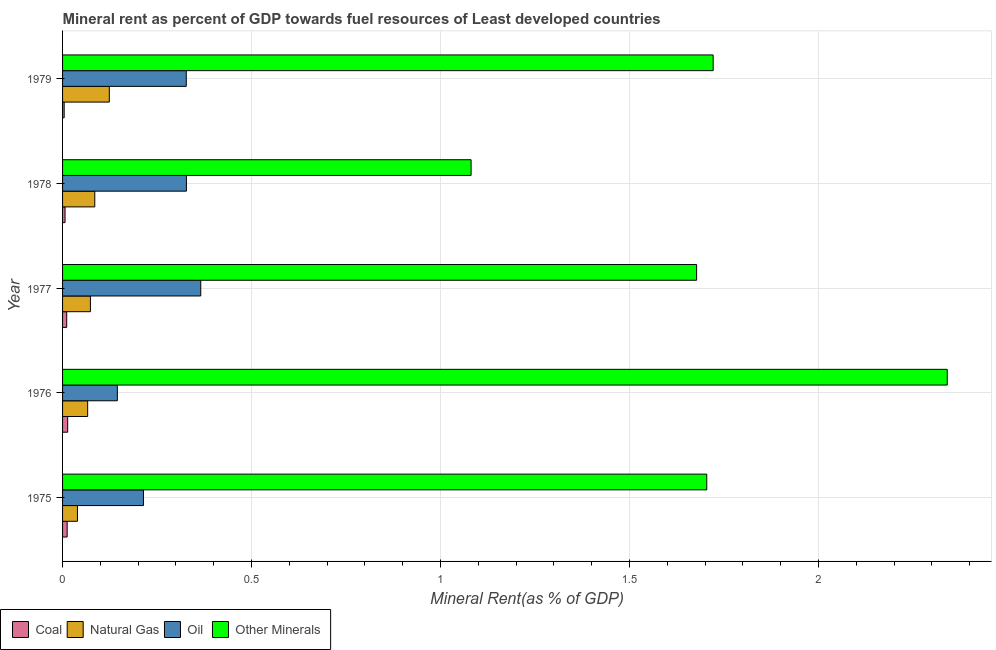How many different coloured bars are there?
Offer a very short reply. 4. How many groups of bars are there?
Offer a very short reply. 5. How many bars are there on the 2nd tick from the top?
Keep it short and to the point. 4. How many bars are there on the 1st tick from the bottom?
Your answer should be very brief. 4. What is the label of the 4th group of bars from the top?
Provide a succinct answer. 1976. What is the natural gas rent in 1975?
Keep it short and to the point. 0.04. Across all years, what is the maximum oil rent?
Provide a succinct answer. 0.37. Across all years, what is the minimum  rent of other minerals?
Your answer should be very brief. 1.08. In which year was the natural gas rent minimum?
Keep it short and to the point. 1975. What is the total  rent of other minerals in the graph?
Provide a succinct answer. 8.53. What is the difference between the natural gas rent in 1977 and that in 1978?
Your answer should be compact. -0.01. What is the difference between the oil rent in 1977 and the coal rent in 1976?
Ensure brevity in your answer.  0.35. What is the average oil rent per year?
Provide a succinct answer. 0.28. In the year 1979, what is the difference between the  rent of other minerals and natural gas rent?
Make the answer very short. 1.6. What is the ratio of the coal rent in 1976 to that in 1977?
Give a very brief answer. 1.24. Is the natural gas rent in 1975 less than that in 1976?
Your response must be concise. Yes. Is the difference between the  rent of other minerals in 1975 and 1979 greater than the difference between the coal rent in 1975 and 1979?
Ensure brevity in your answer.  No. What is the difference between the highest and the second highest oil rent?
Provide a succinct answer. 0.04. In how many years, is the oil rent greater than the average oil rent taken over all years?
Your answer should be very brief. 3. Is the sum of the oil rent in 1976 and 1977 greater than the maximum natural gas rent across all years?
Your answer should be compact. Yes. What does the 3rd bar from the top in 1978 represents?
Your response must be concise. Natural Gas. What does the 4th bar from the bottom in 1977 represents?
Keep it short and to the point. Other Minerals. Are all the bars in the graph horizontal?
Make the answer very short. Yes. What is the difference between two consecutive major ticks on the X-axis?
Give a very brief answer. 0.5. Are the values on the major ticks of X-axis written in scientific E-notation?
Make the answer very short. No. Does the graph contain any zero values?
Ensure brevity in your answer.  No. How are the legend labels stacked?
Provide a succinct answer. Horizontal. What is the title of the graph?
Give a very brief answer. Mineral rent as percent of GDP towards fuel resources of Least developed countries. Does "Energy" appear as one of the legend labels in the graph?
Make the answer very short. No. What is the label or title of the X-axis?
Your answer should be compact. Mineral Rent(as % of GDP). What is the label or title of the Y-axis?
Keep it short and to the point. Year. What is the Mineral Rent(as % of GDP) in Coal in 1975?
Your response must be concise. 0.01. What is the Mineral Rent(as % of GDP) in Natural Gas in 1975?
Your response must be concise. 0.04. What is the Mineral Rent(as % of GDP) in Oil in 1975?
Offer a very short reply. 0.21. What is the Mineral Rent(as % of GDP) of Other Minerals in 1975?
Provide a succinct answer. 1.7. What is the Mineral Rent(as % of GDP) of Coal in 1976?
Provide a short and direct response. 0.01. What is the Mineral Rent(as % of GDP) of Natural Gas in 1976?
Give a very brief answer. 0.07. What is the Mineral Rent(as % of GDP) of Oil in 1976?
Make the answer very short. 0.14. What is the Mineral Rent(as % of GDP) of Other Minerals in 1976?
Provide a short and direct response. 2.34. What is the Mineral Rent(as % of GDP) of Coal in 1977?
Your answer should be compact. 0.01. What is the Mineral Rent(as % of GDP) of Natural Gas in 1977?
Give a very brief answer. 0.07. What is the Mineral Rent(as % of GDP) of Oil in 1977?
Your answer should be very brief. 0.37. What is the Mineral Rent(as % of GDP) of Other Minerals in 1977?
Provide a succinct answer. 1.68. What is the Mineral Rent(as % of GDP) in Coal in 1978?
Keep it short and to the point. 0.01. What is the Mineral Rent(as % of GDP) in Natural Gas in 1978?
Make the answer very short. 0.09. What is the Mineral Rent(as % of GDP) in Oil in 1978?
Your answer should be very brief. 0.33. What is the Mineral Rent(as % of GDP) of Other Minerals in 1978?
Offer a terse response. 1.08. What is the Mineral Rent(as % of GDP) of Coal in 1979?
Give a very brief answer. 0. What is the Mineral Rent(as % of GDP) in Natural Gas in 1979?
Give a very brief answer. 0.12. What is the Mineral Rent(as % of GDP) of Oil in 1979?
Offer a terse response. 0.33. What is the Mineral Rent(as % of GDP) in Other Minerals in 1979?
Provide a short and direct response. 1.72. Across all years, what is the maximum Mineral Rent(as % of GDP) of Coal?
Your answer should be compact. 0.01. Across all years, what is the maximum Mineral Rent(as % of GDP) of Natural Gas?
Offer a very short reply. 0.12. Across all years, what is the maximum Mineral Rent(as % of GDP) in Oil?
Keep it short and to the point. 0.37. Across all years, what is the maximum Mineral Rent(as % of GDP) of Other Minerals?
Provide a succinct answer. 2.34. Across all years, what is the minimum Mineral Rent(as % of GDP) of Coal?
Offer a terse response. 0. Across all years, what is the minimum Mineral Rent(as % of GDP) of Natural Gas?
Your response must be concise. 0.04. Across all years, what is the minimum Mineral Rent(as % of GDP) of Oil?
Ensure brevity in your answer.  0.14. Across all years, what is the minimum Mineral Rent(as % of GDP) in Other Minerals?
Provide a succinct answer. 1.08. What is the total Mineral Rent(as % of GDP) in Coal in the graph?
Make the answer very short. 0.05. What is the total Mineral Rent(as % of GDP) in Natural Gas in the graph?
Your response must be concise. 0.39. What is the total Mineral Rent(as % of GDP) in Oil in the graph?
Offer a very short reply. 1.38. What is the total Mineral Rent(as % of GDP) of Other Minerals in the graph?
Your answer should be compact. 8.53. What is the difference between the Mineral Rent(as % of GDP) of Coal in 1975 and that in 1976?
Give a very brief answer. -0. What is the difference between the Mineral Rent(as % of GDP) in Natural Gas in 1975 and that in 1976?
Your response must be concise. -0.03. What is the difference between the Mineral Rent(as % of GDP) in Oil in 1975 and that in 1976?
Make the answer very short. 0.07. What is the difference between the Mineral Rent(as % of GDP) in Other Minerals in 1975 and that in 1976?
Give a very brief answer. -0.64. What is the difference between the Mineral Rent(as % of GDP) of Coal in 1975 and that in 1977?
Offer a terse response. 0. What is the difference between the Mineral Rent(as % of GDP) in Natural Gas in 1975 and that in 1977?
Provide a short and direct response. -0.03. What is the difference between the Mineral Rent(as % of GDP) of Oil in 1975 and that in 1977?
Ensure brevity in your answer.  -0.15. What is the difference between the Mineral Rent(as % of GDP) of Other Minerals in 1975 and that in 1977?
Provide a short and direct response. 0.03. What is the difference between the Mineral Rent(as % of GDP) of Coal in 1975 and that in 1978?
Make the answer very short. 0.01. What is the difference between the Mineral Rent(as % of GDP) of Natural Gas in 1975 and that in 1978?
Provide a succinct answer. -0.05. What is the difference between the Mineral Rent(as % of GDP) in Oil in 1975 and that in 1978?
Ensure brevity in your answer.  -0.11. What is the difference between the Mineral Rent(as % of GDP) in Other Minerals in 1975 and that in 1978?
Provide a succinct answer. 0.62. What is the difference between the Mineral Rent(as % of GDP) in Coal in 1975 and that in 1979?
Offer a very short reply. 0.01. What is the difference between the Mineral Rent(as % of GDP) of Natural Gas in 1975 and that in 1979?
Keep it short and to the point. -0.08. What is the difference between the Mineral Rent(as % of GDP) of Oil in 1975 and that in 1979?
Your answer should be compact. -0.11. What is the difference between the Mineral Rent(as % of GDP) in Other Minerals in 1975 and that in 1979?
Your answer should be compact. -0.02. What is the difference between the Mineral Rent(as % of GDP) in Coal in 1976 and that in 1977?
Make the answer very short. 0. What is the difference between the Mineral Rent(as % of GDP) of Natural Gas in 1976 and that in 1977?
Provide a short and direct response. -0.01. What is the difference between the Mineral Rent(as % of GDP) of Oil in 1976 and that in 1977?
Your response must be concise. -0.22. What is the difference between the Mineral Rent(as % of GDP) of Other Minerals in 1976 and that in 1977?
Provide a succinct answer. 0.66. What is the difference between the Mineral Rent(as % of GDP) of Coal in 1976 and that in 1978?
Make the answer very short. 0.01. What is the difference between the Mineral Rent(as % of GDP) in Natural Gas in 1976 and that in 1978?
Make the answer very short. -0.02. What is the difference between the Mineral Rent(as % of GDP) of Oil in 1976 and that in 1978?
Offer a very short reply. -0.18. What is the difference between the Mineral Rent(as % of GDP) of Other Minerals in 1976 and that in 1978?
Provide a short and direct response. 1.26. What is the difference between the Mineral Rent(as % of GDP) in Coal in 1976 and that in 1979?
Ensure brevity in your answer.  0.01. What is the difference between the Mineral Rent(as % of GDP) of Natural Gas in 1976 and that in 1979?
Make the answer very short. -0.06. What is the difference between the Mineral Rent(as % of GDP) of Oil in 1976 and that in 1979?
Make the answer very short. -0.18. What is the difference between the Mineral Rent(as % of GDP) of Other Minerals in 1976 and that in 1979?
Make the answer very short. 0.62. What is the difference between the Mineral Rent(as % of GDP) of Coal in 1977 and that in 1978?
Provide a succinct answer. 0. What is the difference between the Mineral Rent(as % of GDP) in Natural Gas in 1977 and that in 1978?
Provide a short and direct response. -0.01. What is the difference between the Mineral Rent(as % of GDP) in Oil in 1977 and that in 1978?
Your response must be concise. 0.04. What is the difference between the Mineral Rent(as % of GDP) in Other Minerals in 1977 and that in 1978?
Ensure brevity in your answer.  0.6. What is the difference between the Mineral Rent(as % of GDP) in Coal in 1977 and that in 1979?
Make the answer very short. 0.01. What is the difference between the Mineral Rent(as % of GDP) of Oil in 1977 and that in 1979?
Ensure brevity in your answer.  0.04. What is the difference between the Mineral Rent(as % of GDP) in Other Minerals in 1977 and that in 1979?
Provide a succinct answer. -0.04. What is the difference between the Mineral Rent(as % of GDP) in Coal in 1978 and that in 1979?
Your response must be concise. 0. What is the difference between the Mineral Rent(as % of GDP) in Natural Gas in 1978 and that in 1979?
Make the answer very short. -0.04. What is the difference between the Mineral Rent(as % of GDP) of Oil in 1978 and that in 1979?
Make the answer very short. 0. What is the difference between the Mineral Rent(as % of GDP) in Other Minerals in 1978 and that in 1979?
Offer a very short reply. -0.64. What is the difference between the Mineral Rent(as % of GDP) of Coal in 1975 and the Mineral Rent(as % of GDP) of Natural Gas in 1976?
Your answer should be very brief. -0.05. What is the difference between the Mineral Rent(as % of GDP) of Coal in 1975 and the Mineral Rent(as % of GDP) of Oil in 1976?
Offer a terse response. -0.13. What is the difference between the Mineral Rent(as % of GDP) of Coal in 1975 and the Mineral Rent(as % of GDP) of Other Minerals in 1976?
Ensure brevity in your answer.  -2.33. What is the difference between the Mineral Rent(as % of GDP) in Natural Gas in 1975 and the Mineral Rent(as % of GDP) in Oil in 1976?
Provide a short and direct response. -0.11. What is the difference between the Mineral Rent(as % of GDP) of Natural Gas in 1975 and the Mineral Rent(as % of GDP) of Other Minerals in 1976?
Make the answer very short. -2.3. What is the difference between the Mineral Rent(as % of GDP) in Oil in 1975 and the Mineral Rent(as % of GDP) in Other Minerals in 1976?
Your answer should be compact. -2.13. What is the difference between the Mineral Rent(as % of GDP) in Coal in 1975 and the Mineral Rent(as % of GDP) in Natural Gas in 1977?
Provide a succinct answer. -0.06. What is the difference between the Mineral Rent(as % of GDP) in Coal in 1975 and the Mineral Rent(as % of GDP) in Oil in 1977?
Your answer should be compact. -0.35. What is the difference between the Mineral Rent(as % of GDP) of Coal in 1975 and the Mineral Rent(as % of GDP) of Other Minerals in 1977?
Provide a short and direct response. -1.67. What is the difference between the Mineral Rent(as % of GDP) in Natural Gas in 1975 and the Mineral Rent(as % of GDP) in Oil in 1977?
Provide a succinct answer. -0.33. What is the difference between the Mineral Rent(as % of GDP) in Natural Gas in 1975 and the Mineral Rent(as % of GDP) in Other Minerals in 1977?
Your answer should be compact. -1.64. What is the difference between the Mineral Rent(as % of GDP) in Oil in 1975 and the Mineral Rent(as % of GDP) in Other Minerals in 1977?
Your answer should be compact. -1.46. What is the difference between the Mineral Rent(as % of GDP) of Coal in 1975 and the Mineral Rent(as % of GDP) of Natural Gas in 1978?
Offer a very short reply. -0.07. What is the difference between the Mineral Rent(as % of GDP) in Coal in 1975 and the Mineral Rent(as % of GDP) in Oil in 1978?
Make the answer very short. -0.32. What is the difference between the Mineral Rent(as % of GDP) of Coal in 1975 and the Mineral Rent(as % of GDP) of Other Minerals in 1978?
Provide a short and direct response. -1.07. What is the difference between the Mineral Rent(as % of GDP) of Natural Gas in 1975 and the Mineral Rent(as % of GDP) of Oil in 1978?
Provide a short and direct response. -0.29. What is the difference between the Mineral Rent(as % of GDP) in Natural Gas in 1975 and the Mineral Rent(as % of GDP) in Other Minerals in 1978?
Provide a succinct answer. -1.04. What is the difference between the Mineral Rent(as % of GDP) in Oil in 1975 and the Mineral Rent(as % of GDP) in Other Minerals in 1978?
Give a very brief answer. -0.87. What is the difference between the Mineral Rent(as % of GDP) of Coal in 1975 and the Mineral Rent(as % of GDP) of Natural Gas in 1979?
Offer a very short reply. -0.11. What is the difference between the Mineral Rent(as % of GDP) of Coal in 1975 and the Mineral Rent(as % of GDP) of Oil in 1979?
Make the answer very short. -0.32. What is the difference between the Mineral Rent(as % of GDP) of Coal in 1975 and the Mineral Rent(as % of GDP) of Other Minerals in 1979?
Offer a very short reply. -1.71. What is the difference between the Mineral Rent(as % of GDP) in Natural Gas in 1975 and the Mineral Rent(as % of GDP) in Oil in 1979?
Provide a short and direct response. -0.29. What is the difference between the Mineral Rent(as % of GDP) in Natural Gas in 1975 and the Mineral Rent(as % of GDP) in Other Minerals in 1979?
Your answer should be compact. -1.68. What is the difference between the Mineral Rent(as % of GDP) of Oil in 1975 and the Mineral Rent(as % of GDP) of Other Minerals in 1979?
Keep it short and to the point. -1.51. What is the difference between the Mineral Rent(as % of GDP) of Coal in 1976 and the Mineral Rent(as % of GDP) of Natural Gas in 1977?
Your response must be concise. -0.06. What is the difference between the Mineral Rent(as % of GDP) in Coal in 1976 and the Mineral Rent(as % of GDP) in Oil in 1977?
Provide a succinct answer. -0.35. What is the difference between the Mineral Rent(as % of GDP) of Coal in 1976 and the Mineral Rent(as % of GDP) of Other Minerals in 1977?
Make the answer very short. -1.66. What is the difference between the Mineral Rent(as % of GDP) in Natural Gas in 1976 and the Mineral Rent(as % of GDP) in Oil in 1977?
Offer a very short reply. -0.3. What is the difference between the Mineral Rent(as % of GDP) in Natural Gas in 1976 and the Mineral Rent(as % of GDP) in Other Minerals in 1977?
Your answer should be very brief. -1.61. What is the difference between the Mineral Rent(as % of GDP) in Oil in 1976 and the Mineral Rent(as % of GDP) in Other Minerals in 1977?
Offer a terse response. -1.53. What is the difference between the Mineral Rent(as % of GDP) in Coal in 1976 and the Mineral Rent(as % of GDP) in Natural Gas in 1978?
Your answer should be very brief. -0.07. What is the difference between the Mineral Rent(as % of GDP) of Coal in 1976 and the Mineral Rent(as % of GDP) of Oil in 1978?
Offer a very short reply. -0.31. What is the difference between the Mineral Rent(as % of GDP) in Coal in 1976 and the Mineral Rent(as % of GDP) in Other Minerals in 1978?
Offer a very short reply. -1.07. What is the difference between the Mineral Rent(as % of GDP) of Natural Gas in 1976 and the Mineral Rent(as % of GDP) of Oil in 1978?
Your answer should be very brief. -0.26. What is the difference between the Mineral Rent(as % of GDP) in Natural Gas in 1976 and the Mineral Rent(as % of GDP) in Other Minerals in 1978?
Ensure brevity in your answer.  -1.01. What is the difference between the Mineral Rent(as % of GDP) in Oil in 1976 and the Mineral Rent(as % of GDP) in Other Minerals in 1978?
Your answer should be very brief. -0.94. What is the difference between the Mineral Rent(as % of GDP) of Coal in 1976 and the Mineral Rent(as % of GDP) of Natural Gas in 1979?
Your response must be concise. -0.11. What is the difference between the Mineral Rent(as % of GDP) in Coal in 1976 and the Mineral Rent(as % of GDP) in Oil in 1979?
Make the answer very short. -0.31. What is the difference between the Mineral Rent(as % of GDP) in Coal in 1976 and the Mineral Rent(as % of GDP) in Other Minerals in 1979?
Your answer should be compact. -1.71. What is the difference between the Mineral Rent(as % of GDP) in Natural Gas in 1976 and the Mineral Rent(as % of GDP) in Oil in 1979?
Provide a succinct answer. -0.26. What is the difference between the Mineral Rent(as % of GDP) in Natural Gas in 1976 and the Mineral Rent(as % of GDP) in Other Minerals in 1979?
Your answer should be very brief. -1.66. What is the difference between the Mineral Rent(as % of GDP) of Oil in 1976 and the Mineral Rent(as % of GDP) of Other Minerals in 1979?
Your answer should be compact. -1.58. What is the difference between the Mineral Rent(as % of GDP) in Coal in 1977 and the Mineral Rent(as % of GDP) in Natural Gas in 1978?
Your answer should be very brief. -0.07. What is the difference between the Mineral Rent(as % of GDP) in Coal in 1977 and the Mineral Rent(as % of GDP) in Oil in 1978?
Make the answer very short. -0.32. What is the difference between the Mineral Rent(as % of GDP) in Coal in 1977 and the Mineral Rent(as % of GDP) in Other Minerals in 1978?
Offer a very short reply. -1.07. What is the difference between the Mineral Rent(as % of GDP) of Natural Gas in 1977 and the Mineral Rent(as % of GDP) of Oil in 1978?
Provide a succinct answer. -0.25. What is the difference between the Mineral Rent(as % of GDP) in Natural Gas in 1977 and the Mineral Rent(as % of GDP) in Other Minerals in 1978?
Give a very brief answer. -1.01. What is the difference between the Mineral Rent(as % of GDP) of Oil in 1977 and the Mineral Rent(as % of GDP) of Other Minerals in 1978?
Your answer should be compact. -0.72. What is the difference between the Mineral Rent(as % of GDP) in Coal in 1977 and the Mineral Rent(as % of GDP) in Natural Gas in 1979?
Your answer should be very brief. -0.11. What is the difference between the Mineral Rent(as % of GDP) of Coal in 1977 and the Mineral Rent(as % of GDP) of Oil in 1979?
Provide a short and direct response. -0.32. What is the difference between the Mineral Rent(as % of GDP) in Coal in 1977 and the Mineral Rent(as % of GDP) in Other Minerals in 1979?
Ensure brevity in your answer.  -1.71. What is the difference between the Mineral Rent(as % of GDP) in Natural Gas in 1977 and the Mineral Rent(as % of GDP) in Oil in 1979?
Make the answer very short. -0.25. What is the difference between the Mineral Rent(as % of GDP) of Natural Gas in 1977 and the Mineral Rent(as % of GDP) of Other Minerals in 1979?
Give a very brief answer. -1.65. What is the difference between the Mineral Rent(as % of GDP) in Oil in 1977 and the Mineral Rent(as % of GDP) in Other Minerals in 1979?
Offer a terse response. -1.36. What is the difference between the Mineral Rent(as % of GDP) of Coal in 1978 and the Mineral Rent(as % of GDP) of Natural Gas in 1979?
Offer a terse response. -0.12. What is the difference between the Mineral Rent(as % of GDP) in Coal in 1978 and the Mineral Rent(as % of GDP) in Oil in 1979?
Your answer should be compact. -0.32. What is the difference between the Mineral Rent(as % of GDP) in Coal in 1978 and the Mineral Rent(as % of GDP) in Other Minerals in 1979?
Offer a terse response. -1.71. What is the difference between the Mineral Rent(as % of GDP) of Natural Gas in 1978 and the Mineral Rent(as % of GDP) of Oil in 1979?
Offer a very short reply. -0.24. What is the difference between the Mineral Rent(as % of GDP) of Natural Gas in 1978 and the Mineral Rent(as % of GDP) of Other Minerals in 1979?
Your answer should be very brief. -1.64. What is the difference between the Mineral Rent(as % of GDP) in Oil in 1978 and the Mineral Rent(as % of GDP) in Other Minerals in 1979?
Ensure brevity in your answer.  -1.39. What is the average Mineral Rent(as % of GDP) of Coal per year?
Your answer should be compact. 0.01. What is the average Mineral Rent(as % of GDP) of Natural Gas per year?
Your answer should be very brief. 0.08. What is the average Mineral Rent(as % of GDP) in Oil per year?
Your answer should be compact. 0.28. What is the average Mineral Rent(as % of GDP) of Other Minerals per year?
Your answer should be compact. 1.71. In the year 1975, what is the difference between the Mineral Rent(as % of GDP) in Coal and Mineral Rent(as % of GDP) in Natural Gas?
Offer a terse response. -0.03. In the year 1975, what is the difference between the Mineral Rent(as % of GDP) in Coal and Mineral Rent(as % of GDP) in Oil?
Ensure brevity in your answer.  -0.2. In the year 1975, what is the difference between the Mineral Rent(as % of GDP) in Coal and Mineral Rent(as % of GDP) in Other Minerals?
Keep it short and to the point. -1.69. In the year 1975, what is the difference between the Mineral Rent(as % of GDP) in Natural Gas and Mineral Rent(as % of GDP) in Oil?
Ensure brevity in your answer.  -0.17. In the year 1975, what is the difference between the Mineral Rent(as % of GDP) in Natural Gas and Mineral Rent(as % of GDP) in Other Minerals?
Offer a very short reply. -1.67. In the year 1975, what is the difference between the Mineral Rent(as % of GDP) in Oil and Mineral Rent(as % of GDP) in Other Minerals?
Provide a succinct answer. -1.49. In the year 1976, what is the difference between the Mineral Rent(as % of GDP) in Coal and Mineral Rent(as % of GDP) in Natural Gas?
Your answer should be compact. -0.05. In the year 1976, what is the difference between the Mineral Rent(as % of GDP) in Coal and Mineral Rent(as % of GDP) in Oil?
Provide a succinct answer. -0.13. In the year 1976, what is the difference between the Mineral Rent(as % of GDP) in Coal and Mineral Rent(as % of GDP) in Other Minerals?
Your response must be concise. -2.33. In the year 1976, what is the difference between the Mineral Rent(as % of GDP) in Natural Gas and Mineral Rent(as % of GDP) in Oil?
Your answer should be very brief. -0.08. In the year 1976, what is the difference between the Mineral Rent(as % of GDP) of Natural Gas and Mineral Rent(as % of GDP) of Other Minerals?
Offer a very short reply. -2.27. In the year 1976, what is the difference between the Mineral Rent(as % of GDP) of Oil and Mineral Rent(as % of GDP) of Other Minerals?
Make the answer very short. -2.2. In the year 1977, what is the difference between the Mineral Rent(as % of GDP) of Coal and Mineral Rent(as % of GDP) of Natural Gas?
Give a very brief answer. -0.06. In the year 1977, what is the difference between the Mineral Rent(as % of GDP) in Coal and Mineral Rent(as % of GDP) in Oil?
Keep it short and to the point. -0.35. In the year 1977, what is the difference between the Mineral Rent(as % of GDP) in Coal and Mineral Rent(as % of GDP) in Other Minerals?
Your answer should be compact. -1.67. In the year 1977, what is the difference between the Mineral Rent(as % of GDP) of Natural Gas and Mineral Rent(as % of GDP) of Oil?
Your response must be concise. -0.29. In the year 1977, what is the difference between the Mineral Rent(as % of GDP) of Natural Gas and Mineral Rent(as % of GDP) of Other Minerals?
Give a very brief answer. -1.6. In the year 1977, what is the difference between the Mineral Rent(as % of GDP) of Oil and Mineral Rent(as % of GDP) of Other Minerals?
Offer a very short reply. -1.31. In the year 1978, what is the difference between the Mineral Rent(as % of GDP) of Coal and Mineral Rent(as % of GDP) of Natural Gas?
Make the answer very short. -0.08. In the year 1978, what is the difference between the Mineral Rent(as % of GDP) of Coal and Mineral Rent(as % of GDP) of Oil?
Your answer should be compact. -0.32. In the year 1978, what is the difference between the Mineral Rent(as % of GDP) of Coal and Mineral Rent(as % of GDP) of Other Minerals?
Offer a terse response. -1.07. In the year 1978, what is the difference between the Mineral Rent(as % of GDP) in Natural Gas and Mineral Rent(as % of GDP) in Oil?
Offer a terse response. -0.24. In the year 1978, what is the difference between the Mineral Rent(as % of GDP) in Natural Gas and Mineral Rent(as % of GDP) in Other Minerals?
Keep it short and to the point. -1. In the year 1978, what is the difference between the Mineral Rent(as % of GDP) in Oil and Mineral Rent(as % of GDP) in Other Minerals?
Keep it short and to the point. -0.75. In the year 1979, what is the difference between the Mineral Rent(as % of GDP) in Coal and Mineral Rent(as % of GDP) in Natural Gas?
Offer a terse response. -0.12. In the year 1979, what is the difference between the Mineral Rent(as % of GDP) of Coal and Mineral Rent(as % of GDP) of Oil?
Make the answer very short. -0.32. In the year 1979, what is the difference between the Mineral Rent(as % of GDP) of Coal and Mineral Rent(as % of GDP) of Other Minerals?
Your response must be concise. -1.72. In the year 1979, what is the difference between the Mineral Rent(as % of GDP) of Natural Gas and Mineral Rent(as % of GDP) of Oil?
Offer a terse response. -0.2. In the year 1979, what is the difference between the Mineral Rent(as % of GDP) of Natural Gas and Mineral Rent(as % of GDP) of Other Minerals?
Give a very brief answer. -1.6. In the year 1979, what is the difference between the Mineral Rent(as % of GDP) in Oil and Mineral Rent(as % of GDP) in Other Minerals?
Ensure brevity in your answer.  -1.39. What is the ratio of the Mineral Rent(as % of GDP) of Coal in 1975 to that in 1976?
Keep it short and to the point. 0.9. What is the ratio of the Mineral Rent(as % of GDP) of Natural Gas in 1975 to that in 1976?
Keep it short and to the point. 0.59. What is the ratio of the Mineral Rent(as % of GDP) of Oil in 1975 to that in 1976?
Make the answer very short. 1.48. What is the ratio of the Mineral Rent(as % of GDP) in Other Minerals in 1975 to that in 1976?
Ensure brevity in your answer.  0.73. What is the ratio of the Mineral Rent(as % of GDP) in Coal in 1975 to that in 1977?
Make the answer very short. 1.11. What is the ratio of the Mineral Rent(as % of GDP) in Natural Gas in 1975 to that in 1977?
Your answer should be compact. 0.53. What is the ratio of the Mineral Rent(as % of GDP) of Oil in 1975 to that in 1977?
Ensure brevity in your answer.  0.59. What is the ratio of the Mineral Rent(as % of GDP) in Coal in 1975 to that in 1978?
Your answer should be very brief. 1.85. What is the ratio of the Mineral Rent(as % of GDP) in Natural Gas in 1975 to that in 1978?
Your answer should be compact. 0.46. What is the ratio of the Mineral Rent(as % of GDP) in Oil in 1975 to that in 1978?
Ensure brevity in your answer.  0.65. What is the ratio of the Mineral Rent(as % of GDP) in Other Minerals in 1975 to that in 1978?
Offer a very short reply. 1.58. What is the ratio of the Mineral Rent(as % of GDP) of Coal in 1975 to that in 1979?
Offer a very short reply. 2.85. What is the ratio of the Mineral Rent(as % of GDP) in Natural Gas in 1975 to that in 1979?
Provide a succinct answer. 0.32. What is the ratio of the Mineral Rent(as % of GDP) of Oil in 1975 to that in 1979?
Offer a terse response. 0.65. What is the ratio of the Mineral Rent(as % of GDP) of Other Minerals in 1975 to that in 1979?
Offer a very short reply. 0.99. What is the ratio of the Mineral Rent(as % of GDP) in Coal in 1976 to that in 1977?
Offer a very short reply. 1.24. What is the ratio of the Mineral Rent(as % of GDP) in Natural Gas in 1976 to that in 1977?
Keep it short and to the point. 0.9. What is the ratio of the Mineral Rent(as % of GDP) in Oil in 1976 to that in 1977?
Offer a terse response. 0.4. What is the ratio of the Mineral Rent(as % of GDP) in Other Minerals in 1976 to that in 1977?
Offer a very short reply. 1.4. What is the ratio of the Mineral Rent(as % of GDP) in Coal in 1976 to that in 1978?
Keep it short and to the point. 2.07. What is the ratio of the Mineral Rent(as % of GDP) of Natural Gas in 1976 to that in 1978?
Offer a terse response. 0.78. What is the ratio of the Mineral Rent(as % of GDP) of Oil in 1976 to that in 1978?
Provide a short and direct response. 0.44. What is the ratio of the Mineral Rent(as % of GDP) in Other Minerals in 1976 to that in 1978?
Offer a terse response. 2.17. What is the ratio of the Mineral Rent(as % of GDP) in Coal in 1976 to that in 1979?
Your answer should be very brief. 3.18. What is the ratio of the Mineral Rent(as % of GDP) in Natural Gas in 1976 to that in 1979?
Offer a terse response. 0.54. What is the ratio of the Mineral Rent(as % of GDP) in Oil in 1976 to that in 1979?
Provide a succinct answer. 0.44. What is the ratio of the Mineral Rent(as % of GDP) of Other Minerals in 1976 to that in 1979?
Offer a terse response. 1.36. What is the ratio of the Mineral Rent(as % of GDP) of Coal in 1977 to that in 1978?
Provide a succinct answer. 1.67. What is the ratio of the Mineral Rent(as % of GDP) of Natural Gas in 1977 to that in 1978?
Provide a succinct answer. 0.86. What is the ratio of the Mineral Rent(as % of GDP) in Oil in 1977 to that in 1978?
Offer a very short reply. 1.12. What is the ratio of the Mineral Rent(as % of GDP) of Other Minerals in 1977 to that in 1978?
Make the answer very short. 1.55. What is the ratio of the Mineral Rent(as % of GDP) of Coal in 1977 to that in 1979?
Your response must be concise. 2.57. What is the ratio of the Mineral Rent(as % of GDP) in Natural Gas in 1977 to that in 1979?
Offer a very short reply. 0.6. What is the ratio of the Mineral Rent(as % of GDP) in Oil in 1977 to that in 1979?
Make the answer very short. 1.12. What is the ratio of the Mineral Rent(as % of GDP) of Other Minerals in 1977 to that in 1979?
Your answer should be very brief. 0.97. What is the ratio of the Mineral Rent(as % of GDP) of Coal in 1978 to that in 1979?
Make the answer very short. 1.54. What is the ratio of the Mineral Rent(as % of GDP) of Natural Gas in 1978 to that in 1979?
Ensure brevity in your answer.  0.69. What is the ratio of the Mineral Rent(as % of GDP) in Other Minerals in 1978 to that in 1979?
Offer a very short reply. 0.63. What is the difference between the highest and the second highest Mineral Rent(as % of GDP) in Coal?
Give a very brief answer. 0. What is the difference between the highest and the second highest Mineral Rent(as % of GDP) in Natural Gas?
Your answer should be compact. 0.04. What is the difference between the highest and the second highest Mineral Rent(as % of GDP) of Oil?
Your answer should be compact. 0.04. What is the difference between the highest and the second highest Mineral Rent(as % of GDP) of Other Minerals?
Offer a terse response. 0.62. What is the difference between the highest and the lowest Mineral Rent(as % of GDP) of Coal?
Offer a terse response. 0.01. What is the difference between the highest and the lowest Mineral Rent(as % of GDP) of Natural Gas?
Your answer should be compact. 0.08. What is the difference between the highest and the lowest Mineral Rent(as % of GDP) in Oil?
Your answer should be compact. 0.22. What is the difference between the highest and the lowest Mineral Rent(as % of GDP) of Other Minerals?
Make the answer very short. 1.26. 